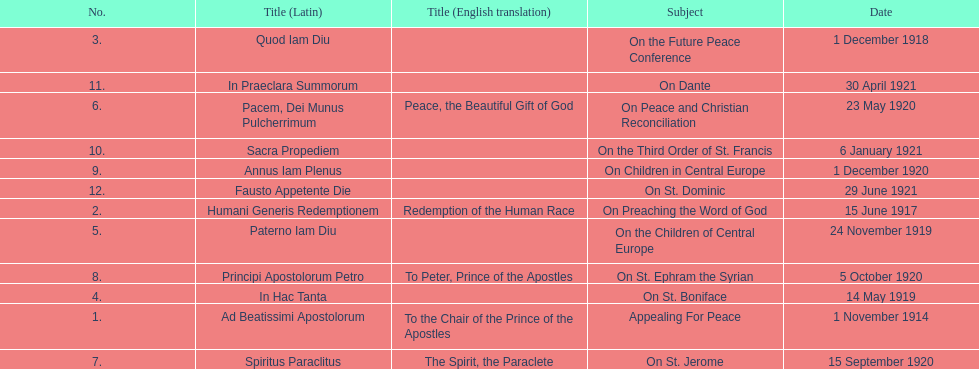What was the number of encyclopedias that had subjects relating specifically to children? 2. 